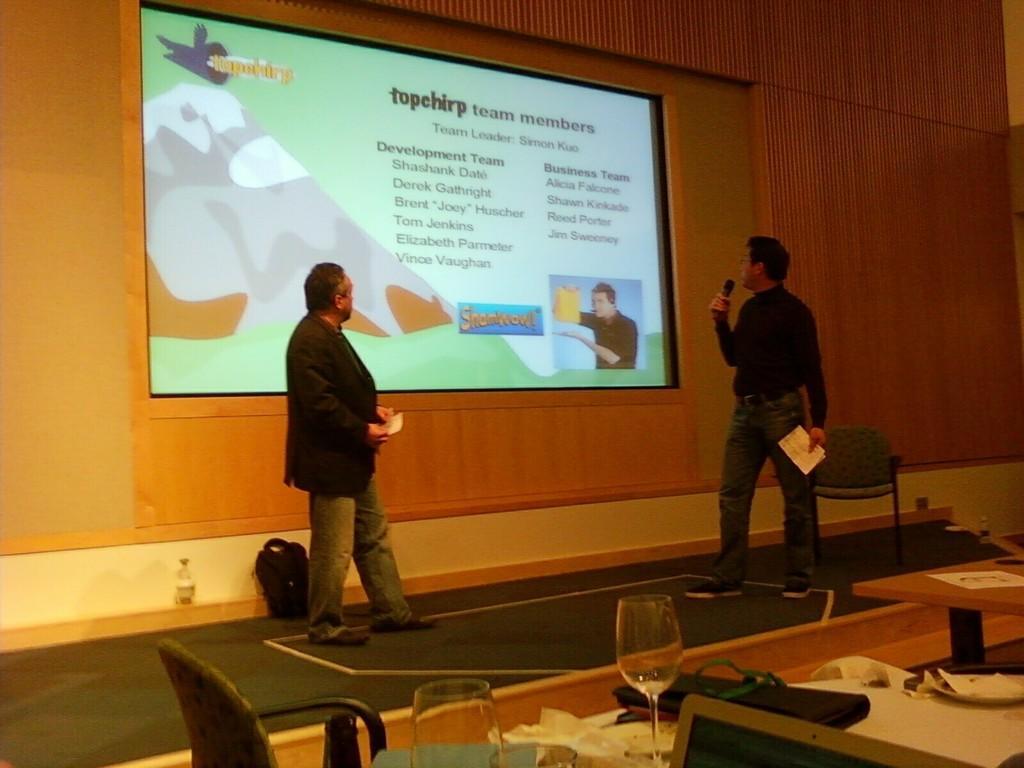In one or two sentences, can you explain what this image depicts? In this picture there is a man standing. There is also another standing holding a mic and paper in his hands. There is a bag, bottle, glass ,plate on the table. There is a screen. 